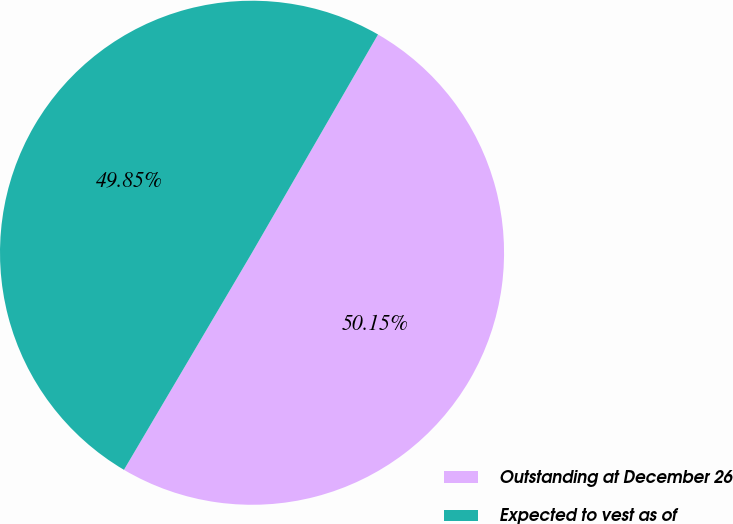Convert chart to OTSL. <chart><loc_0><loc_0><loc_500><loc_500><pie_chart><fcel>Outstanding at December 26<fcel>Expected to vest as of<nl><fcel>50.15%<fcel>49.85%<nl></chart> 